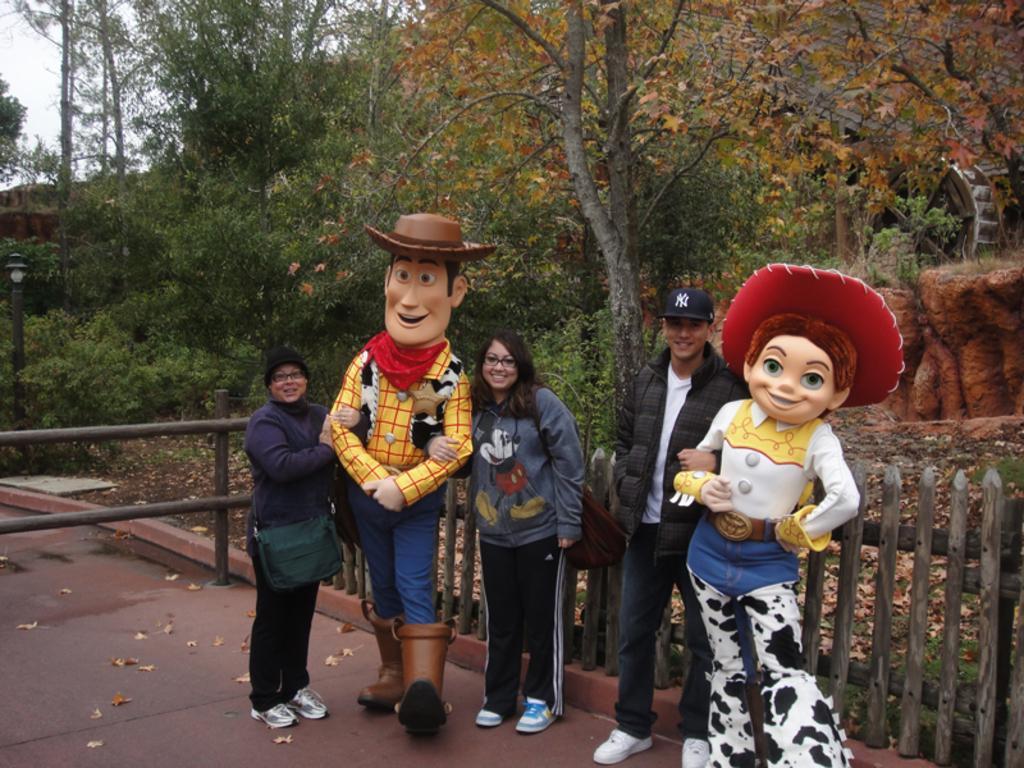Please provide a concise description of this image. In this image I can see few people are standing and I can be smile on their faces. I can also see two of them are wearing specs and two of them are wearing caps. In the background I can see the number of trees and here I can see depiction of two persons. 